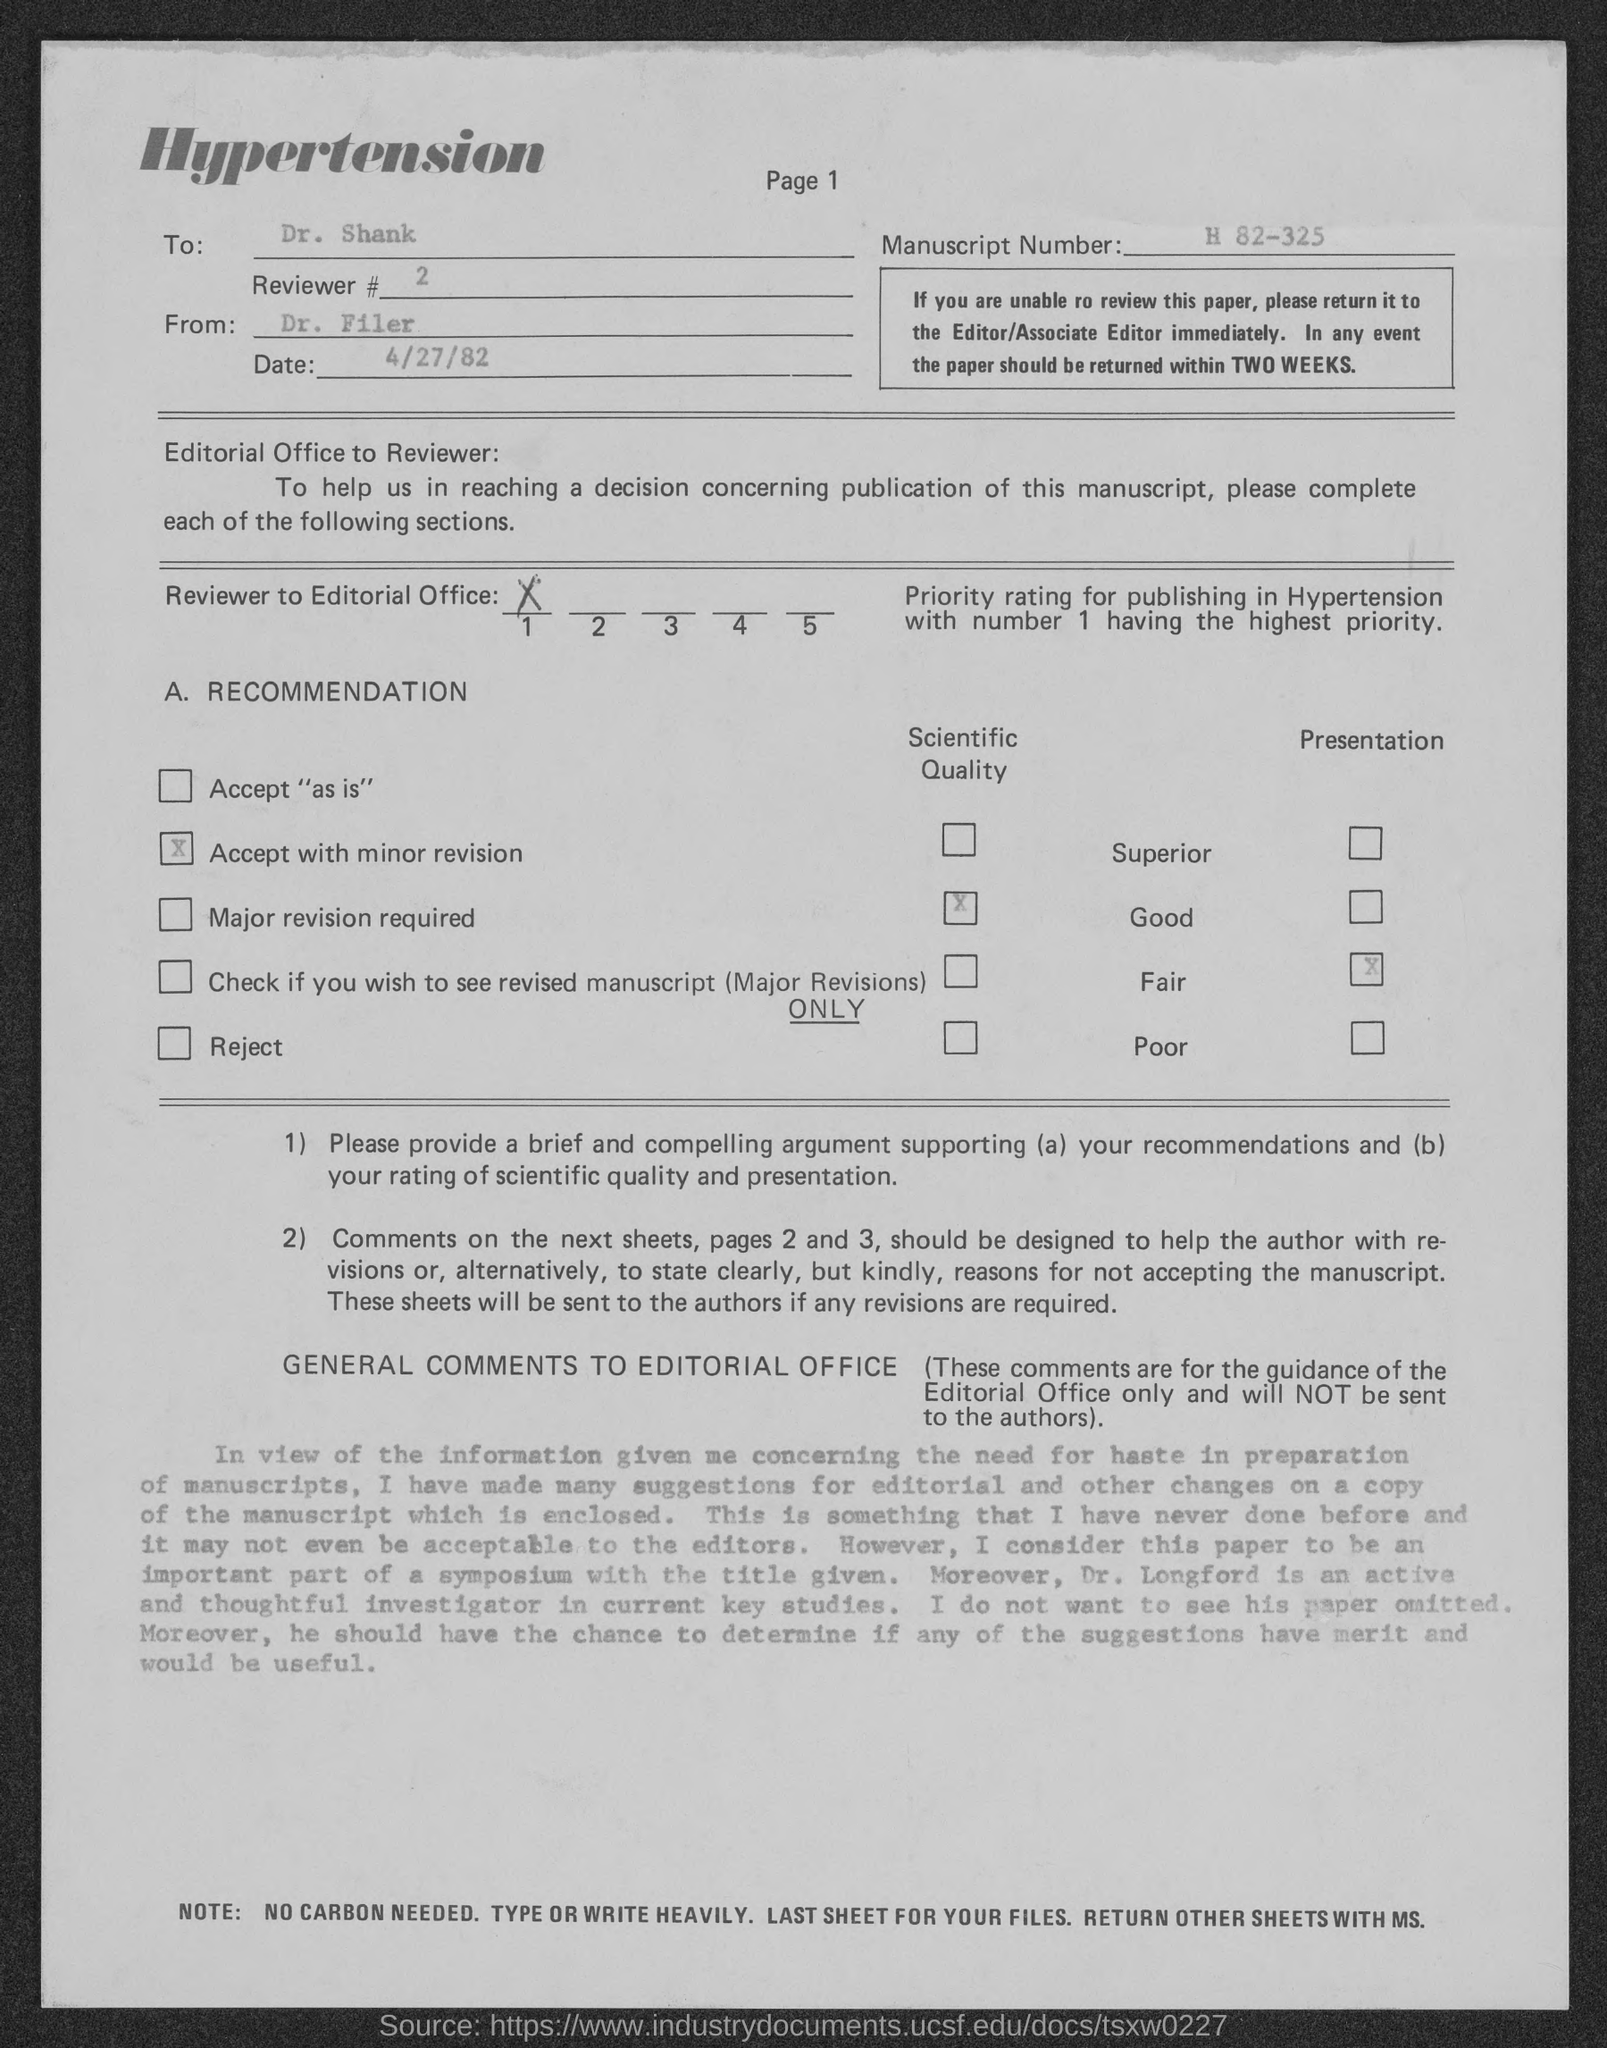To whom the letter is written?
Provide a short and direct response. Dr. Shank. Who wrote the letter?
Your response must be concise. DR. FILER. What is the Manuscript Number?
Offer a very short reply. H 82-325. When is the letter dated?
Make the answer very short. 4/27/82. 